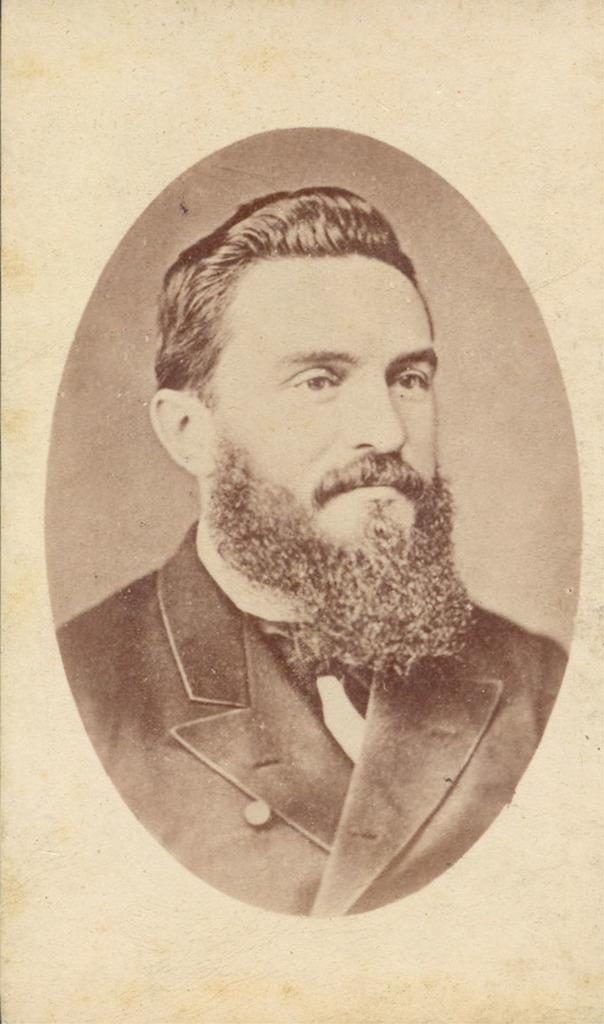What is the main subject of the image? There is a photo of a person in the image. How many giants are visible in the image? There are no giants present in the image; it features a photo of a person. 